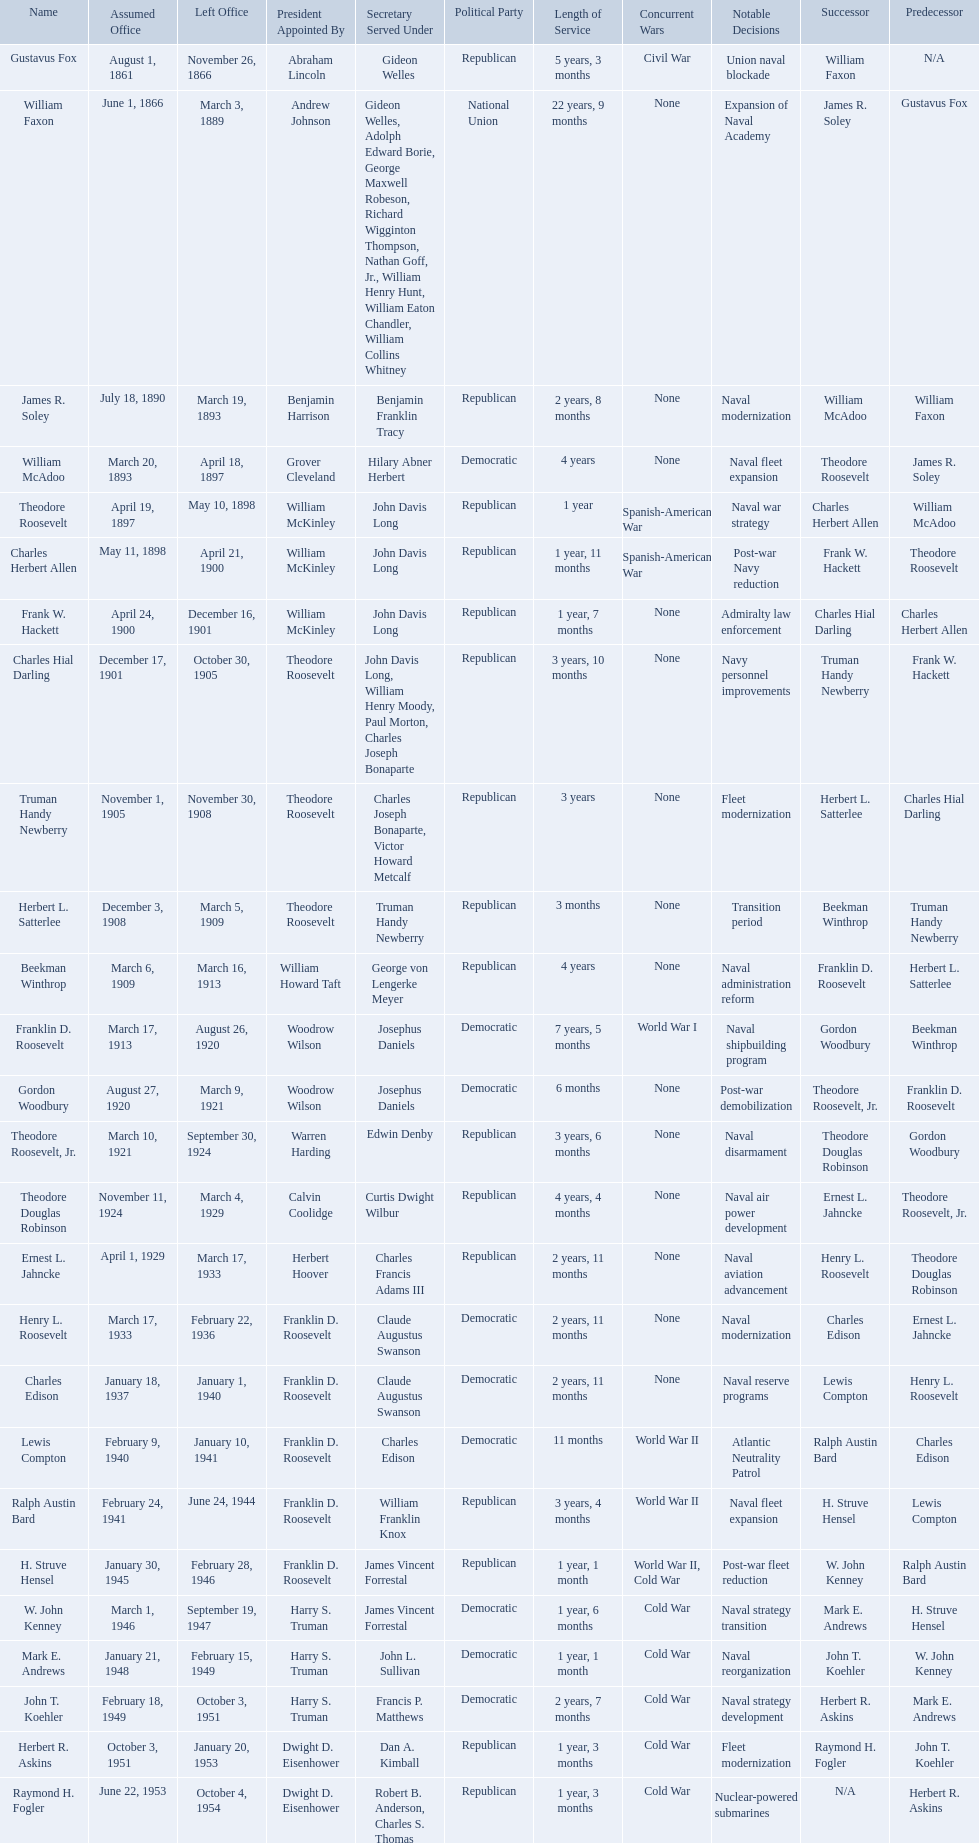Who were all the assistant secretary's of the navy? Gustavus Fox, William Faxon, James R. Soley, William McAdoo, Theodore Roosevelt, Charles Herbert Allen, Frank W. Hackett, Charles Hial Darling, Truman Handy Newberry, Herbert L. Satterlee, Beekman Winthrop, Franklin D. Roosevelt, Gordon Woodbury, Theodore Roosevelt, Jr., Theodore Douglas Robinson, Ernest L. Jahncke, Henry L. Roosevelt, Charles Edison, Lewis Compton, Ralph Austin Bard, H. Struve Hensel, W. John Kenney, Mark E. Andrews, John T. Koehler, Herbert R. Askins, Raymond H. Fogler. What are the various dates they left office in? November 26, 1866, March 3, 1889, March 19, 1893, April 18, 1897, May 10, 1898, April 21, 1900, December 16, 1901, October 30, 1905, November 30, 1908, March 5, 1909, March 16, 1913, August 26, 1920, March 9, 1921, September 30, 1924, March 4, 1929, March 17, 1933, February 22, 1936, January 1, 1940, January 10, 1941, June 24, 1944, February 28, 1946, September 19, 1947, February 15, 1949, October 3, 1951, January 20, 1953, October 4, 1954. Of these dates, which was the date raymond h. fogler left office in? October 4, 1954. Who are all of the assistant secretaries of the navy in the 20th century? Charles Herbert Allen, Frank W. Hackett, Charles Hial Darling, Truman Handy Newberry, Herbert L. Satterlee, Beekman Winthrop, Franklin D. Roosevelt, Gordon Woodbury, Theodore Roosevelt, Jr., Theodore Douglas Robinson, Ernest L. Jahncke, Henry L. Roosevelt, Charles Edison, Lewis Compton, Ralph Austin Bard, H. Struve Hensel, W. John Kenney, Mark E. Andrews, John T. Koehler, Herbert R. Askins, Raymond H. Fogler. What date was assistant secretary of the navy raymond h. fogler appointed? June 22, 1953. What date did assistant secretary of the navy raymond h. fogler leave office? October 4, 1954. What are all the names? Gustavus Fox, William Faxon, James R. Soley, William McAdoo, Theodore Roosevelt, Charles Herbert Allen, Frank W. Hackett, Charles Hial Darling, Truman Handy Newberry, Herbert L. Satterlee, Beekman Winthrop, Franklin D. Roosevelt, Gordon Woodbury, Theodore Roosevelt, Jr., Theodore Douglas Robinson, Ernest L. Jahncke, Henry L. Roosevelt, Charles Edison, Lewis Compton, Ralph Austin Bard, H. Struve Hensel, W. John Kenney, Mark E. Andrews, John T. Koehler, Herbert R. Askins, Raymond H. Fogler. When did they leave office? November 26, 1866, March 3, 1889, March 19, 1893, April 18, 1897, May 10, 1898, April 21, 1900, December 16, 1901, October 30, 1905, November 30, 1908, March 5, 1909, March 16, 1913, August 26, 1920, March 9, 1921, September 30, 1924, March 4, 1929, March 17, 1933, February 22, 1936, January 1, 1940, January 10, 1941, June 24, 1944, February 28, 1946, September 19, 1947, February 15, 1949, October 3, 1951, January 20, 1953, October 4, 1954. And when did raymond h. fogler leave? October 4, 1954. 